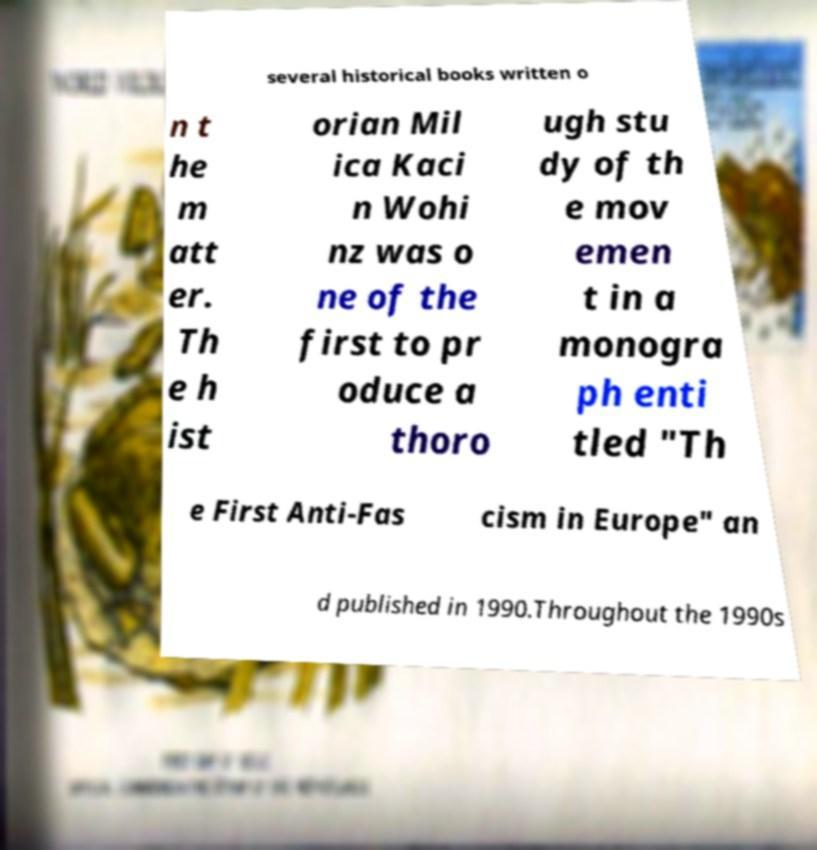Can you read and provide the text displayed in the image?This photo seems to have some interesting text. Can you extract and type it out for me? several historical books written o n t he m att er. Th e h ist orian Mil ica Kaci n Wohi nz was o ne of the first to pr oduce a thoro ugh stu dy of th e mov emen t in a monogra ph enti tled "Th e First Anti-Fas cism in Europe" an d published in 1990.Throughout the 1990s 